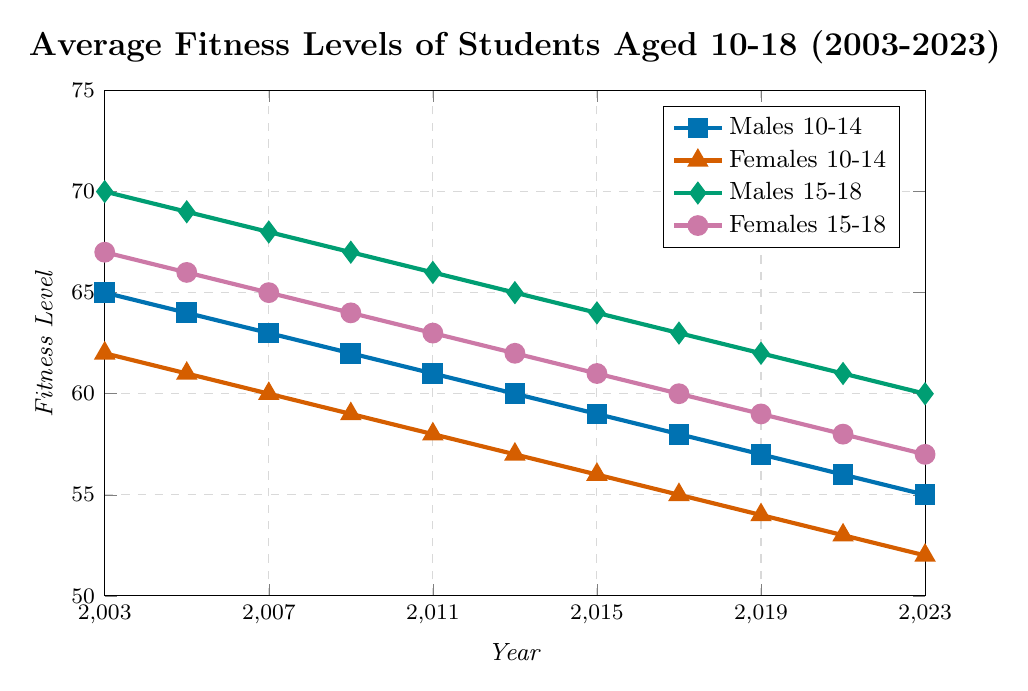Which group had the highest fitness level in 2003? By looking at the data points for all groups in 2003, Males 15-18 had the highest fitness level at 70.
Answer: Males 15-18 What is the trend of fitness levels for Females 10-14 from 2003 to 2023? From 2003 to 2023, the fitness levels for Females 10-14 show a decreasing trend from 62 to 52. Each data point steadily decreases over time.
Answer: Decreasing How did the fitness levels of Males 10-14 change between 2013 and 2023? In 2013, the fitness level for Males 10-14 was 60, and it decreased to 55 by 2023. The difference is 60 - 55 = 5.
Answer: Decreased by 5 Which group had the smallest decline in fitness levels from 2003 to 2023? Calculating the decline: 
- Males 10-14: 65 to 55 (decline of 10)
- Females 10-14: 62 to 52 (decline of 10)
- Males 15-18: 70 to 60 (decline of 10)
- Females 15-18: 67 to 57 (decline of 10) 
Each group has declined by the same amount, which is 10.
Answer: All groups have the same decline Between 2007 and 2011, which gender and age group had the largest decrease in fitness levels? We calculate the difference for each group: 
- Males 10-14: 63 to 61 (decrease of 2)
- Females 10-14: 60 to 58 (decrease of 2)
- Males 15-18: 68 to 66 (decrease of 2)
- Females 15-18: 65 to 63 (decrease of 2)
All decreases are equal, which is 2.
Answer: All groups have the same decrease How much lower was the fitness level of Females 15-18 in 2013 compared to Males 15-18? In 2013, Females 15-18 had a fitness level of 62, and Males 15-18 had 65. The difference is 65 - 62 = 3.
Answer: 3 Describe the pattern of change in fitness levels for Males 15-18 over the 20 years. Males 15-18 show a consistent decrease in fitness levels from 70 in 2003 to 60 in 2023, decreasing by 1 unit every two years.
Answer: Consistent decrease How did the average fitness level for all groups change from 2003 to 2023? Calculate the overall average for all groups:
- 2003: (65+62+70+67)/4 = 66 
- 2023: (55+52+60+57)/4 = 56
The average decreased by 66 - 56 = 10.
Answer: Decreased by 10 Among Males and Females aged 15-18, who had better fitness levels over the entire period? By analyzing the trends:
- Males 15-18 start higher and remain higher than Females 15-18 consistently from 2003 to 2023.
Thus, Males 15-18 had better fitness levels overall.
Answer: Males 15-18 